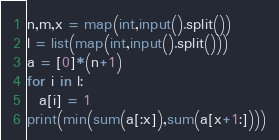<code> <loc_0><loc_0><loc_500><loc_500><_Python_>n,m,x = map(int,input().split())
l = list(map(int,input().split()))
a = [0]*(n+1)
for i in l:
  a[i] = 1
print(min(sum(a[:x]),sum(a[x+1:])))</code> 